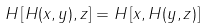Convert formula to latex. <formula><loc_0><loc_0><loc_500><loc_500>H \left [ H ( x , y ) , z \right ] = H \left [ x , H ( y , z ) \right ]</formula> 